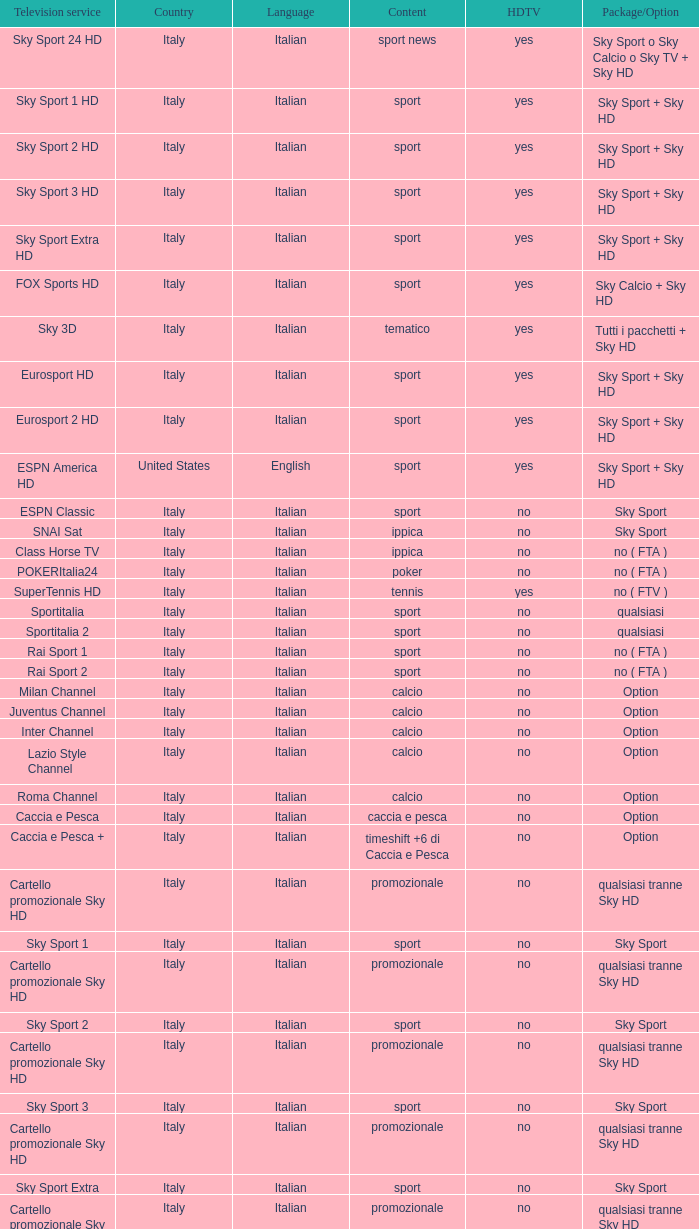When discussing poker, what is the meaning of package/option? No ( fta ). 